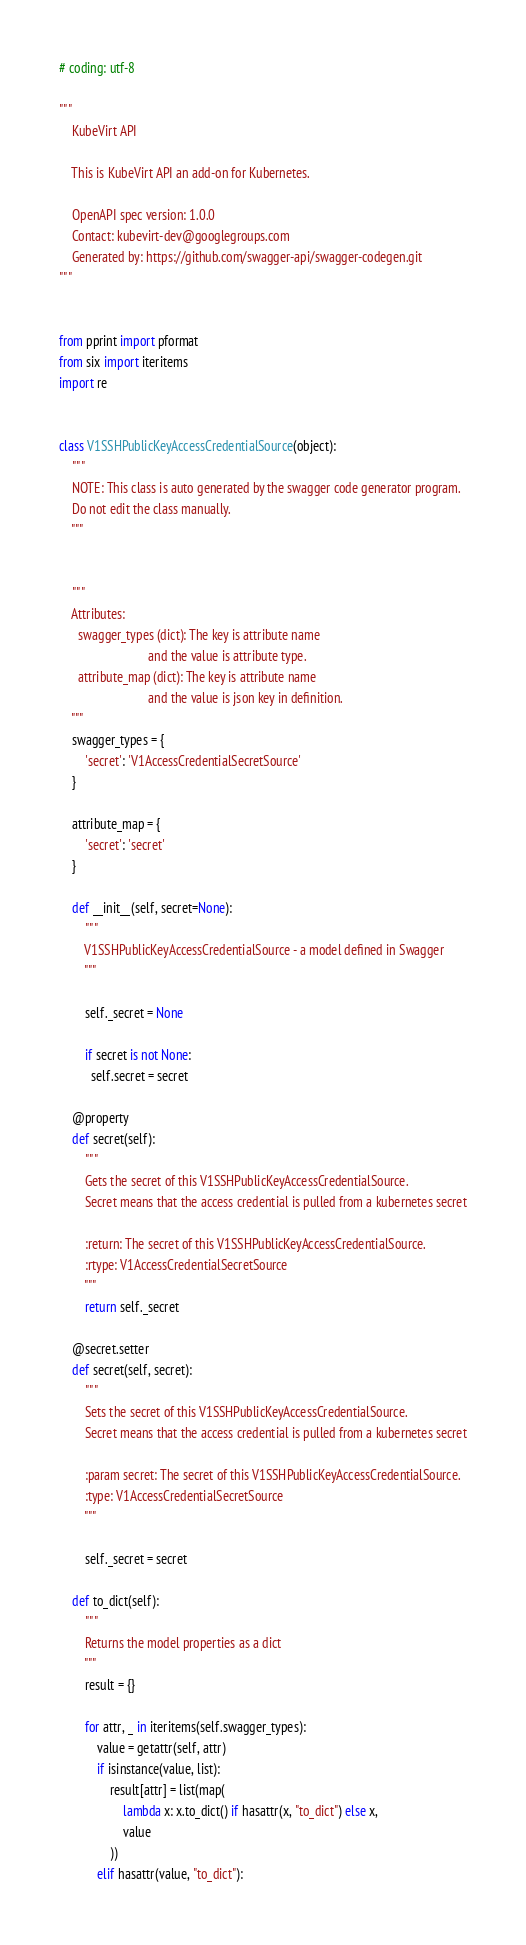Convert code to text. <code><loc_0><loc_0><loc_500><loc_500><_Python_># coding: utf-8

"""
    KubeVirt API

    This is KubeVirt API an add-on for Kubernetes.

    OpenAPI spec version: 1.0.0
    Contact: kubevirt-dev@googlegroups.com
    Generated by: https://github.com/swagger-api/swagger-codegen.git
"""


from pprint import pformat
from six import iteritems
import re


class V1SSHPublicKeyAccessCredentialSource(object):
    """
    NOTE: This class is auto generated by the swagger code generator program.
    Do not edit the class manually.
    """


    """
    Attributes:
      swagger_types (dict): The key is attribute name
                            and the value is attribute type.
      attribute_map (dict): The key is attribute name
                            and the value is json key in definition.
    """
    swagger_types = {
        'secret': 'V1AccessCredentialSecretSource'
    }

    attribute_map = {
        'secret': 'secret'
    }

    def __init__(self, secret=None):
        """
        V1SSHPublicKeyAccessCredentialSource - a model defined in Swagger
        """

        self._secret = None

        if secret is not None:
          self.secret = secret

    @property
    def secret(self):
        """
        Gets the secret of this V1SSHPublicKeyAccessCredentialSource.
        Secret means that the access credential is pulled from a kubernetes secret

        :return: The secret of this V1SSHPublicKeyAccessCredentialSource.
        :rtype: V1AccessCredentialSecretSource
        """
        return self._secret

    @secret.setter
    def secret(self, secret):
        """
        Sets the secret of this V1SSHPublicKeyAccessCredentialSource.
        Secret means that the access credential is pulled from a kubernetes secret

        :param secret: The secret of this V1SSHPublicKeyAccessCredentialSource.
        :type: V1AccessCredentialSecretSource
        """

        self._secret = secret

    def to_dict(self):
        """
        Returns the model properties as a dict
        """
        result = {}

        for attr, _ in iteritems(self.swagger_types):
            value = getattr(self, attr)
            if isinstance(value, list):
                result[attr] = list(map(
                    lambda x: x.to_dict() if hasattr(x, "to_dict") else x,
                    value
                ))
            elif hasattr(value, "to_dict"):</code> 